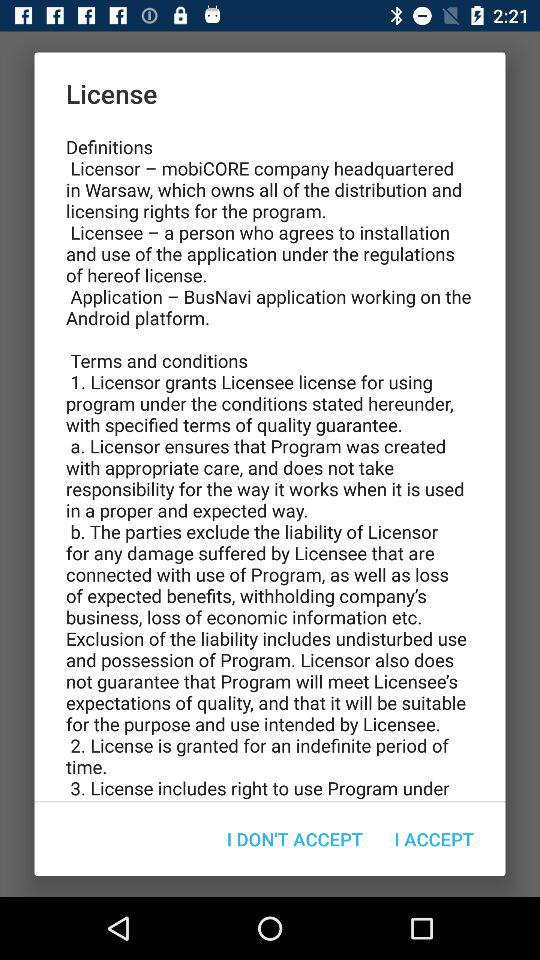How many sections are there in the license agreement?
Answer the question using a single word or phrase. 3 